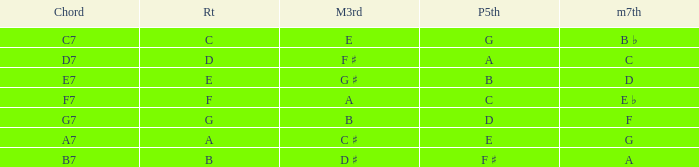What is the Chord with a Major that is third of e? C7. 